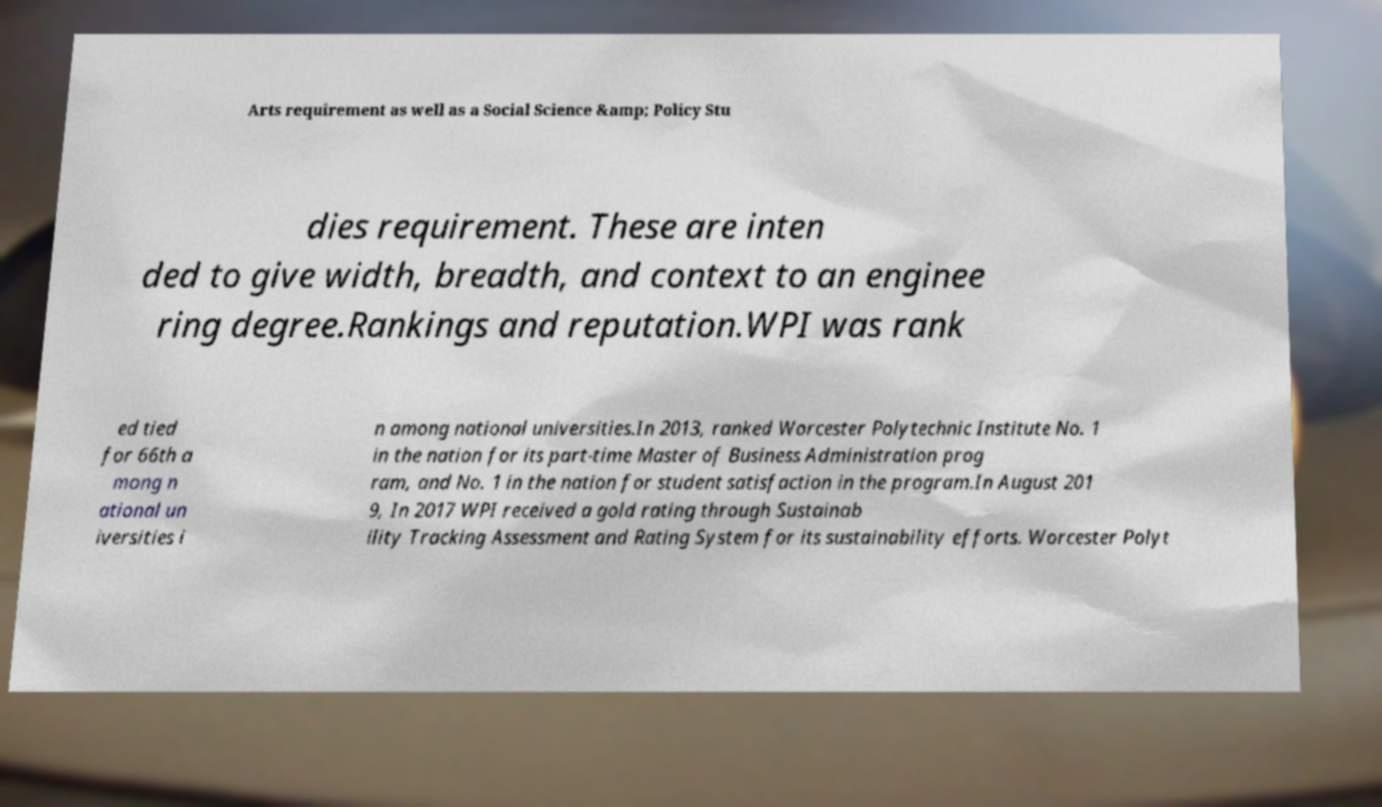Could you extract and type out the text from this image? Arts requirement as well as a Social Science &amp; Policy Stu dies requirement. These are inten ded to give width, breadth, and context to an enginee ring degree.Rankings and reputation.WPI was rank ed tied for 66th a mong n ational un iversities i n among national universities.In 2013, ranked Worcester Polytechnic Institute No. 1 in the nation for its part-time Master of Business Administration prog ram, and No. 1 in the nation for student satisfaction in the program.In August 201 9, In 2017 WPI received a gold rating through Sustainab ility Tracking Assessment and Rating System for its sustainability efforts. Worcester Polyt 